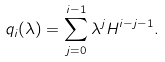<formula> <loc_0><loc_0><loc_500><loc_500>q _ { i } ( \lambda ) = \sum _ { j = 0 } ^ { i - 1 } \lambda ^ { j } H ^ { i - j - 1 } .</formula> 